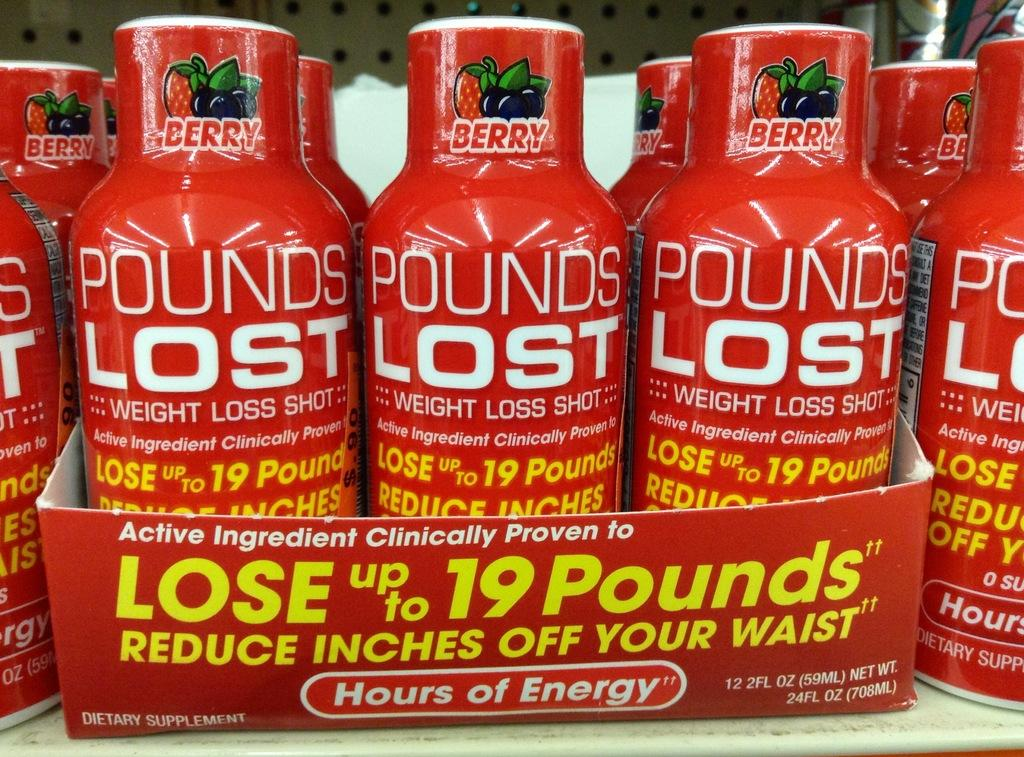<image>
Share a concise interpretation of the image provided. A shelf in a store has red bottles that say Pounds Lost. 